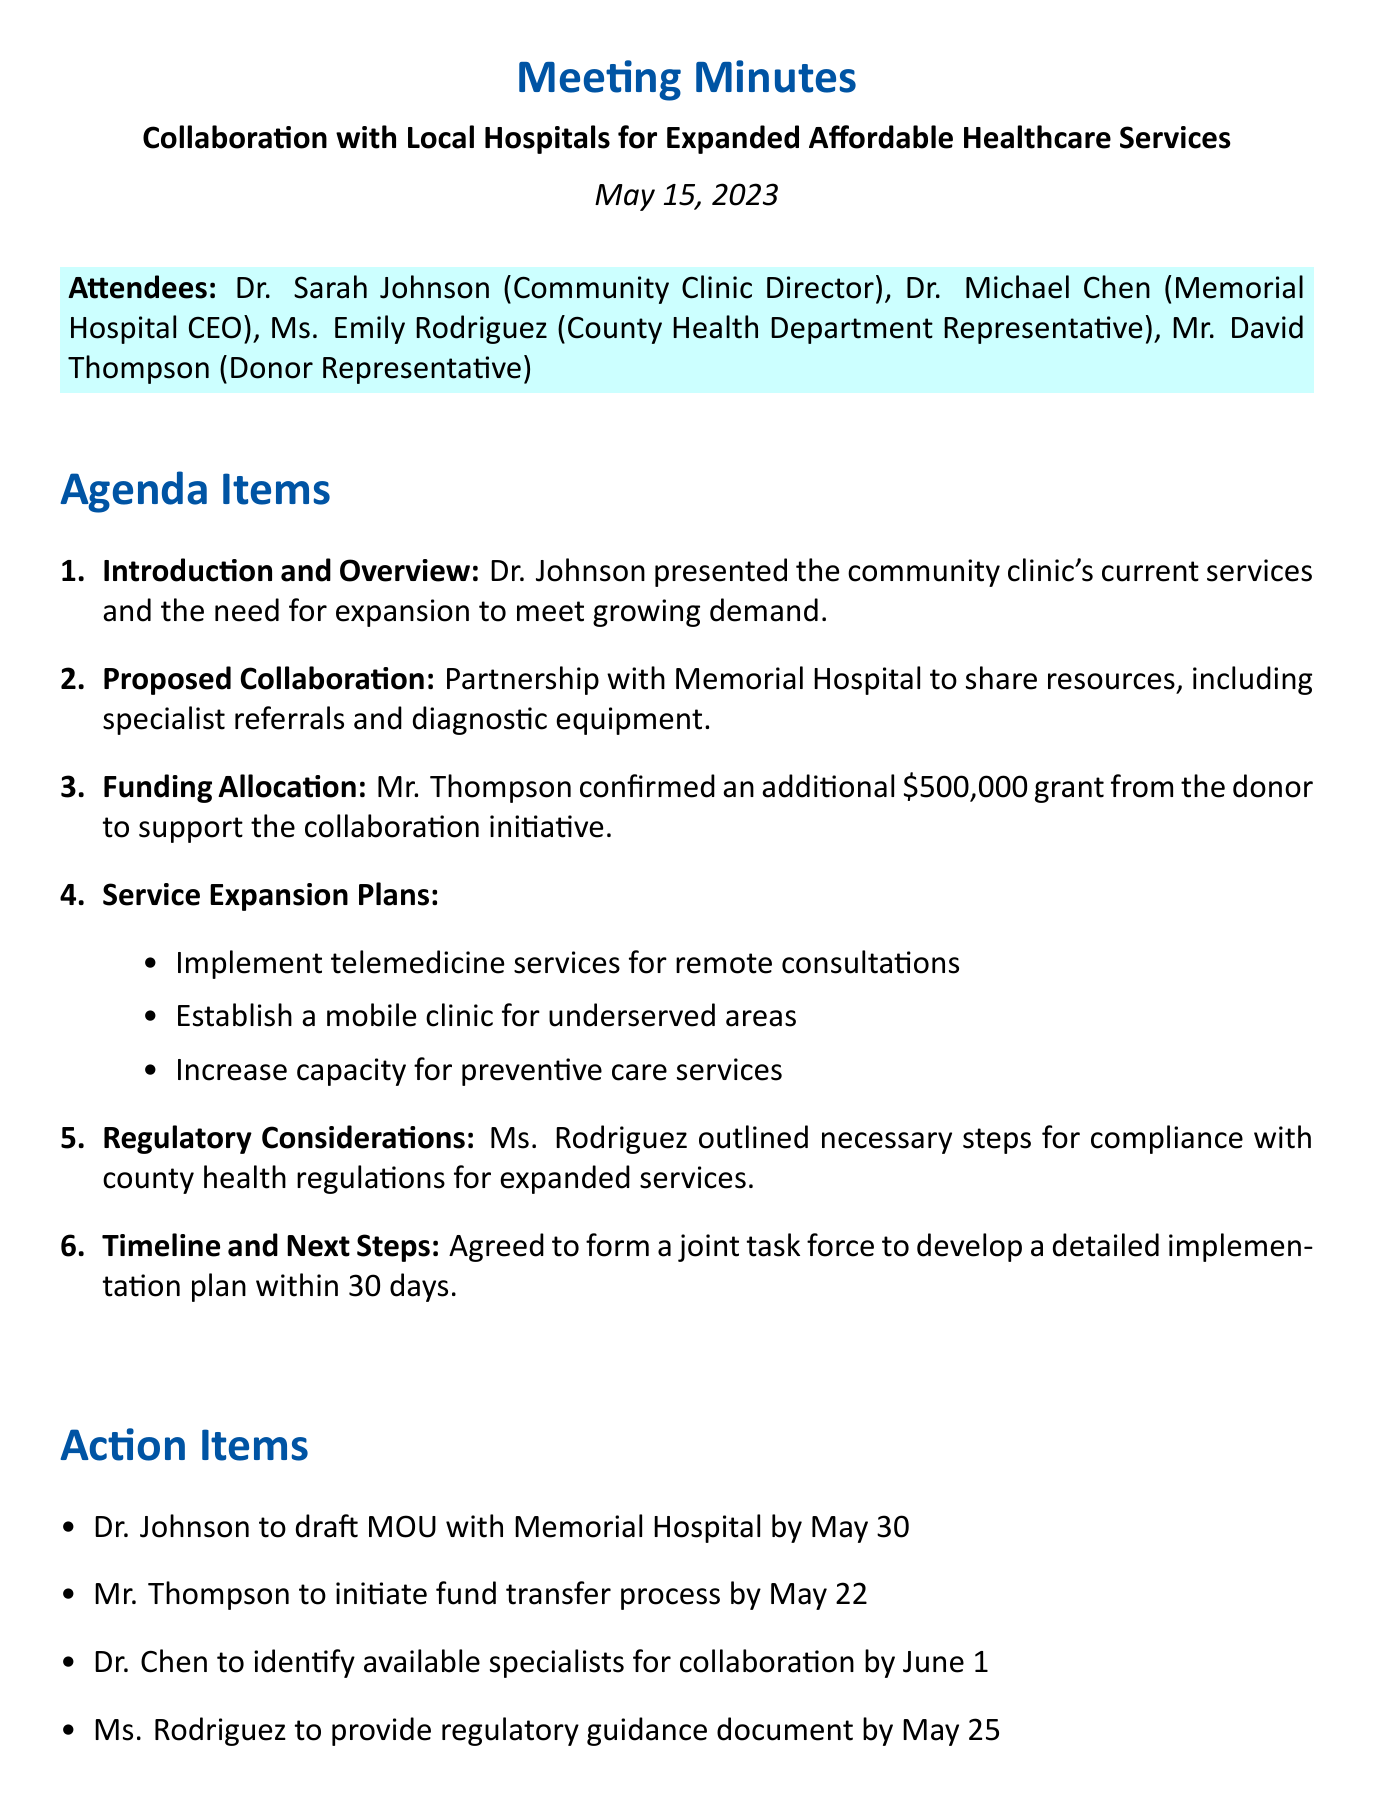What is the date of the meeting? The date of the meeting is explicitly stated at the beginning of the document.
Answer: May 15, 2023 Who confirmed the funding allocation? The funding allocation was confirmed by Mr. Thompson, as mentioned in the document.
Answer: Mr. Thompson How much additional grant was confirmed? The document states that the additional grant amount is specified clearly under the funding allocation section.
Answer: $500,000 What is one of the service expansion plans mentioned? The service expansion plans include several initiatives outlined in the document. One example is implementing telemedicine services for remote consultations.
Answer: Implement telemedicine services for remote consultations Who is responsible for drafting the MOU with Memorial Hospital? The action items list specifies who is responsible for each task, including the MOU with Memorial Hospital.
Answer: Dr. Johnson What will be established for underserved areas? The agenda item on service expansion plans outlines specific services aimed at improving healthcare access, including establishing a mobile clinic.
Answer: Establish a mobile clinic What is the timeline for forming a joint task force? The timeline for action regarding the task force is specified in the timeline and next steps section of the document.
Answer: Within 30 days What detailed document is Ms. Rodriguez providing? The action items indicate that Ms. Rodriguez will provide guidance on a specific area related to compliance.
Answer: Regulatory guidance document 